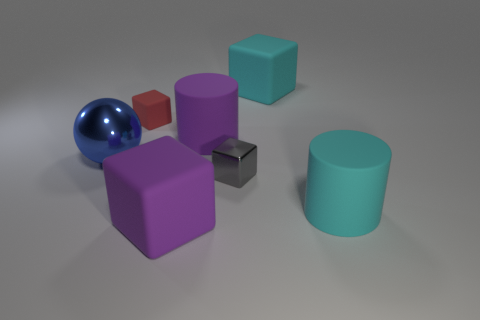There is a cyan object left of the cyan cylinder that is to the right of the small matte object; are there any tiny red rubber objects that are on the left side of it?
Provide a succinct answer. Yes. Are there fewer purple metallic objects than big matte things?
Keep it short and to the point. Yes. There is a small thing that is in front of the large blue metallic thing; does it have the same shape as the red thing?
Make the answer very short. Yes. Are there any red metal cylinders?
Your answer should be very brief. No. What is the color of the small thing that is to the right of the tiny block to the left of the big cylinder behind the large blue shiny object?
Offer a very short reply. Gray. Are there the same number of tiny rubber blocks right of the red object and big cyan matte cylinders that are behind the big purple matte block?
Make the answer very short. No. The cyan object that is the same size as the cyan matte cylinder is what shape?
Provide a short and direct response. Cube. Are there any big shiny objects of the same color as the small rubber object?
Ensure brevity in your answer.  No. There is a red rubber thing behind the metallic ball; what is its shape?
Provide a succinct answer. Cube. What is the color of the small rubber cube?
Offer a terse response. Red. 